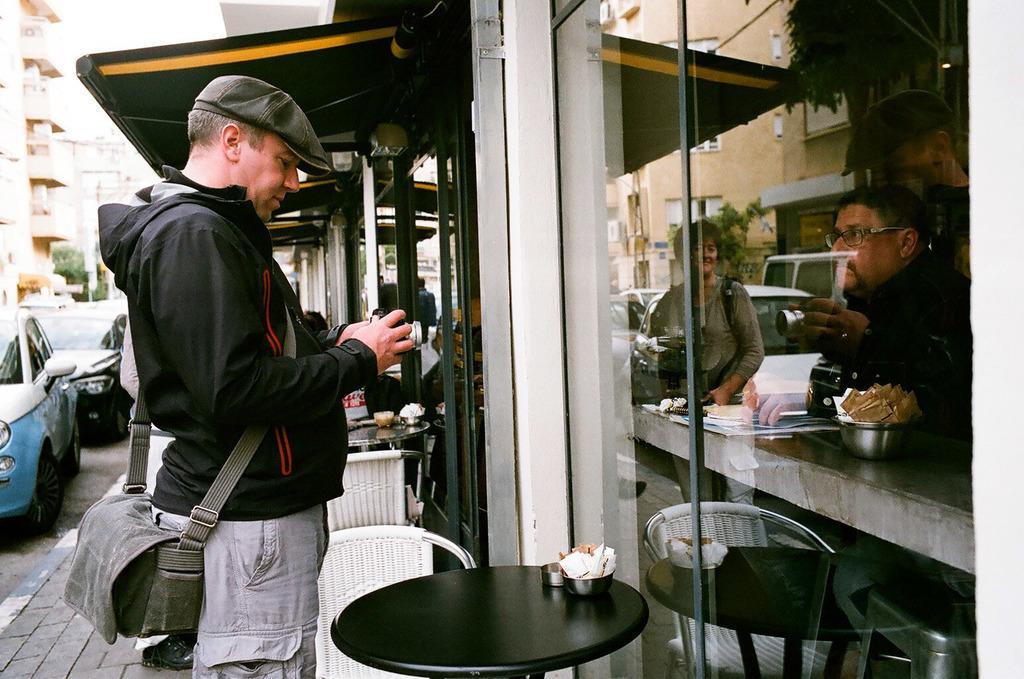In one or two sentences, can you explain what this image depicts? At the top we can see sky. These are building and trees. These are cars on the road. Here we can see one man wearing a bag and a cap standing in front of a table and on the table we can see bowl. Here we can see chairs. on the glass we can see the reflection of this man holding a camera and we can see a women. 